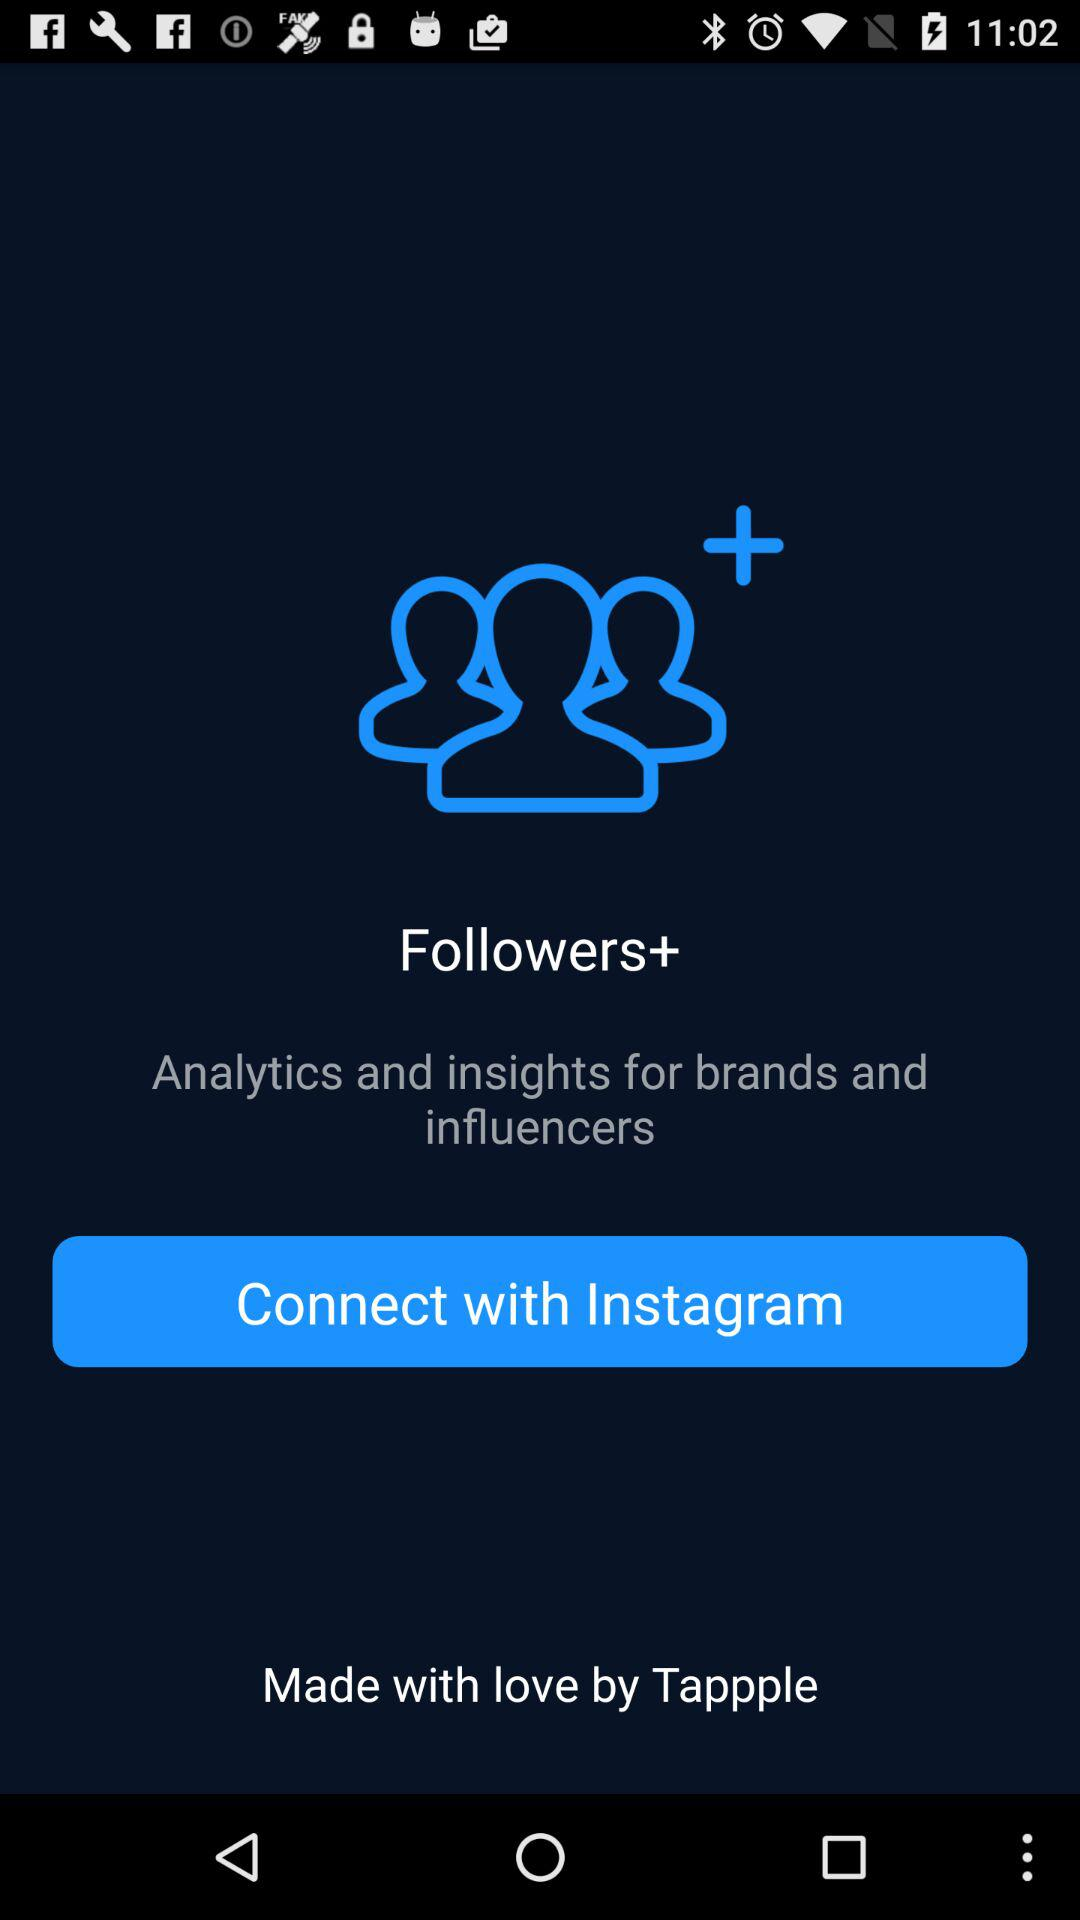Who made the app? The app was made by "Tappple". 